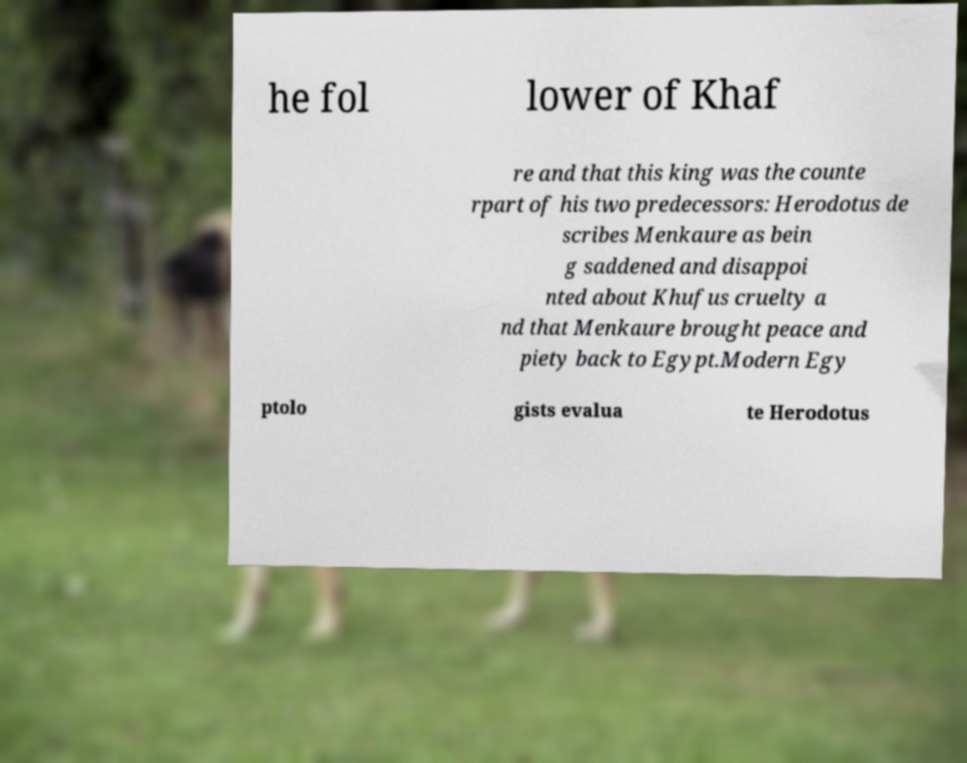What messages or text are displayed in this image? I need them in a readable, typed format. he fol lower of Khaf re and that this king was the counte rpart of his two predecessors: Herodotus de scribes Menkaure as bein g saddened and disappoi nted about Khufus cruelty a nd that Menkaure brought peace and piety back to Egypt.Modern Egy ptolo gists evalua te Herodotus 